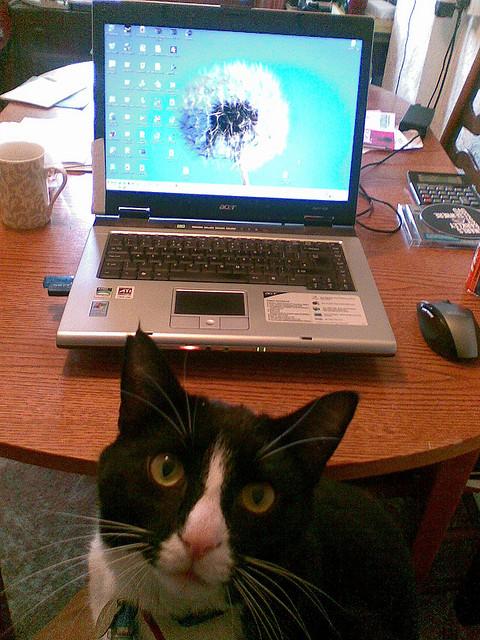Is this cat fixated on the camera?
Short answer required. Yes. How many pets are shown?
Answer briefly. 1. What picture is on the screen?
Short answer required. Dandelion. 